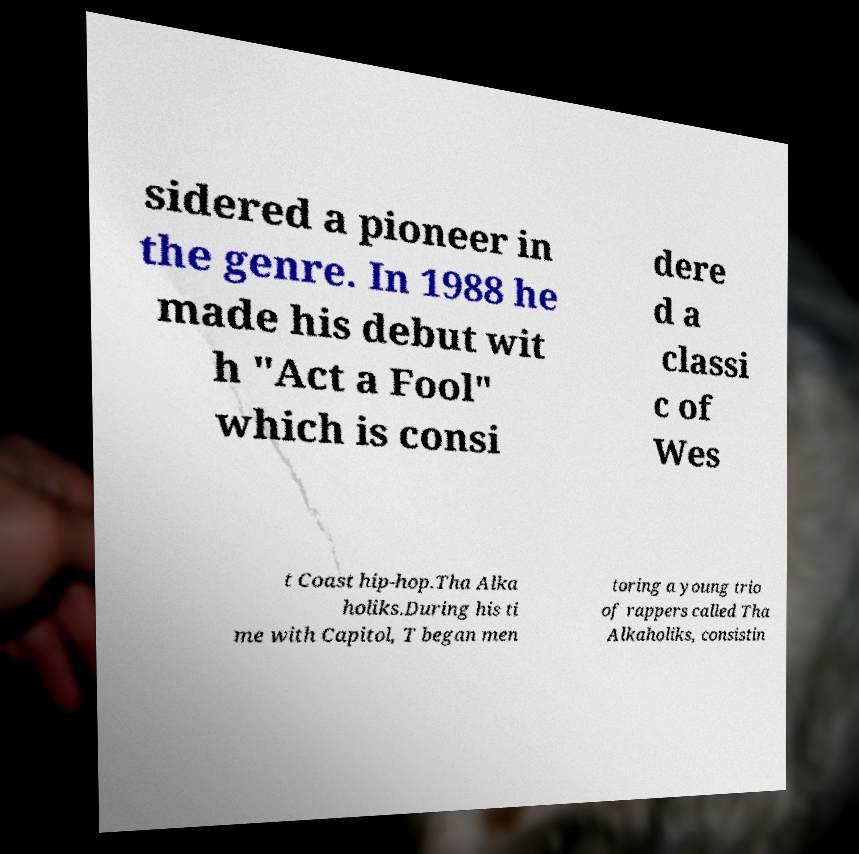What messages or text are displayed in this image? I need them in a readable, typed format. sidered a pioneer in the genre. In 1988 he made his debut wit h "Act a Fool" which is consi dere d a classi c of Wes t Coast hip-hop.Tha Alka holiks.During his ti me with Capitol, T began men toring a young trio of rappers called Tha Alkaholiks, consistin 